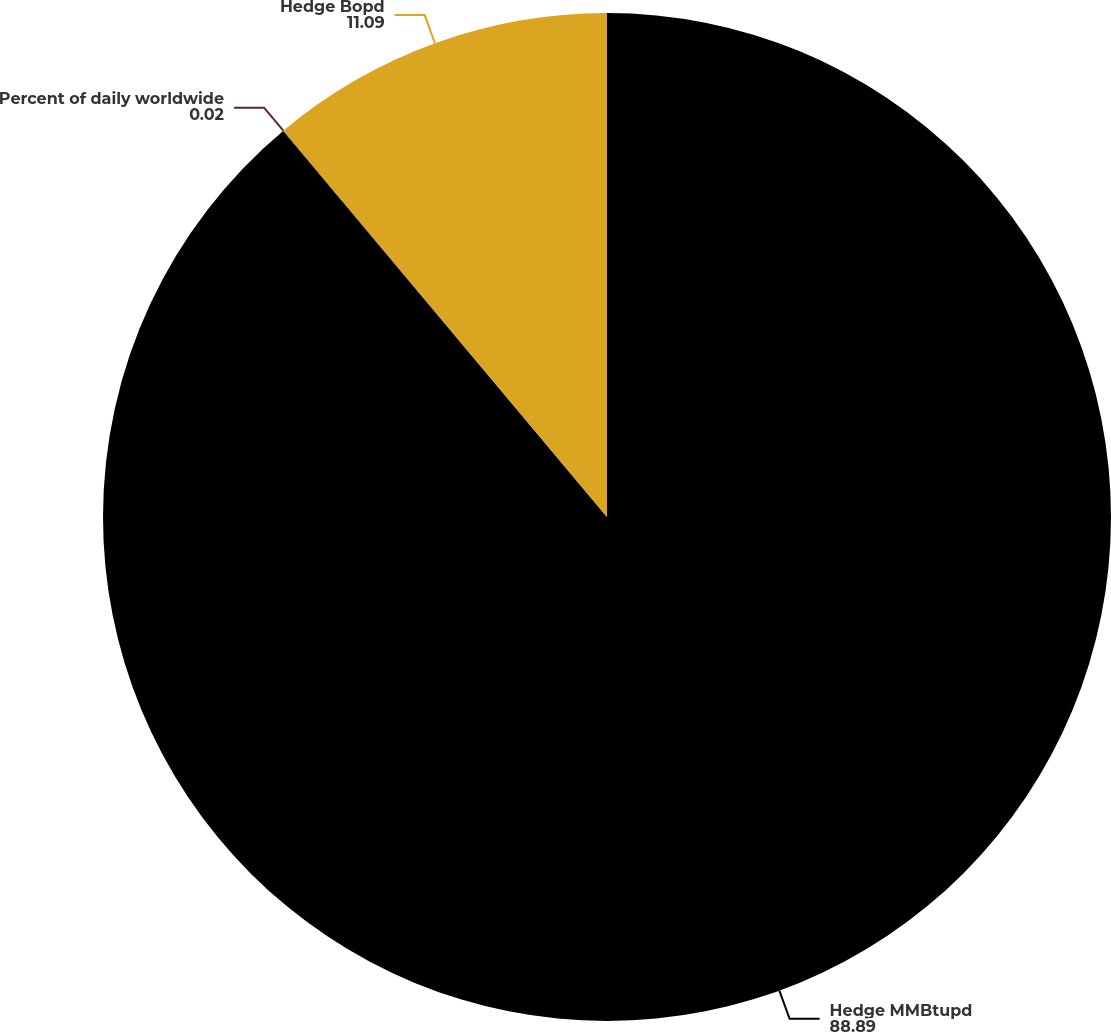Convert chart. <chart><loc_0><loc_0><loc_500><loc_500><pie_chart><fcel>Hedge MMBtupd<fcel>Percent of daily worldwide<fcel>Hedge Bopd<nl><fcel>88.89%<fcel>0.02%<fcel>11.09%<nl></chart> 